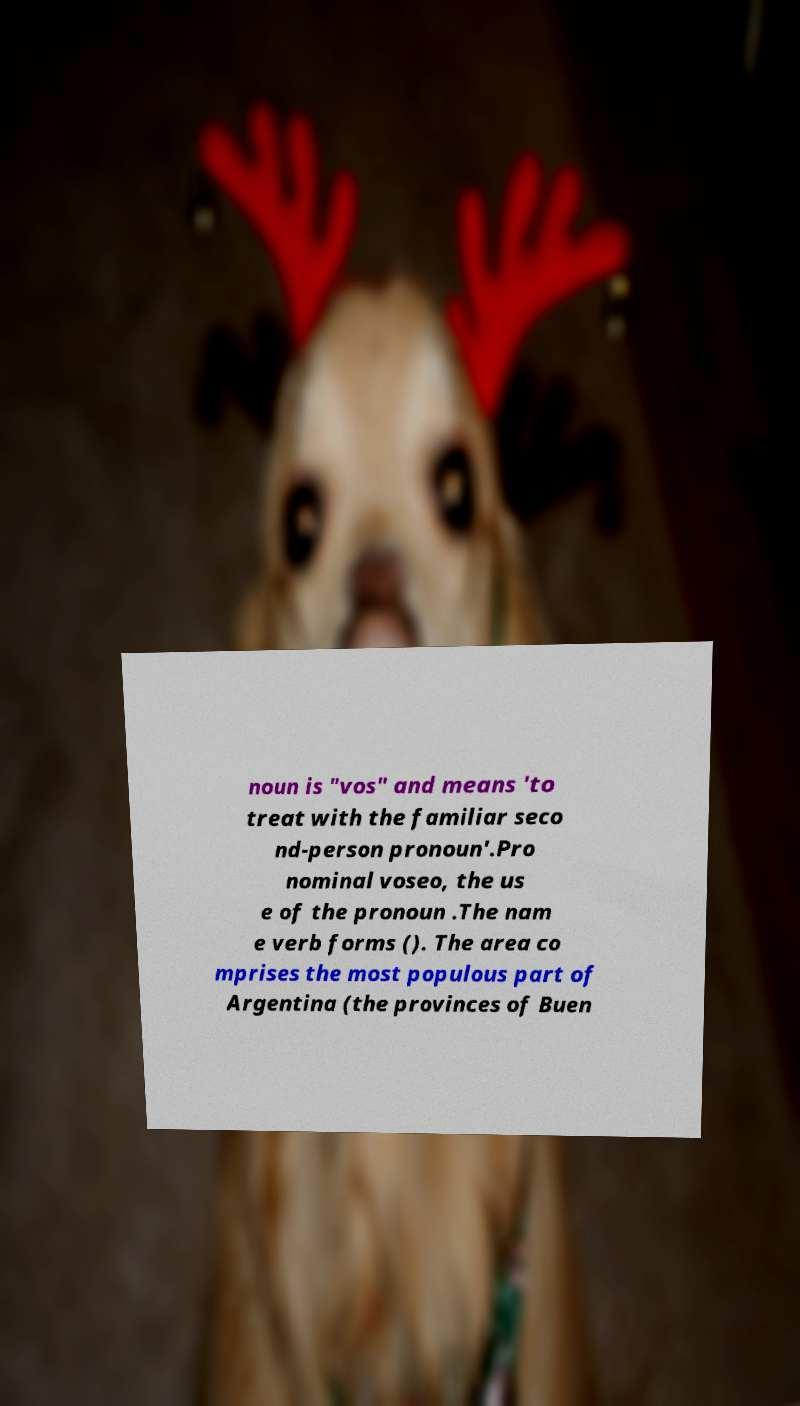Please identify and transcribe the text found in this image. noun is "vos" and means 'to treat with the familiar seco nd-person pronoun'.Pro nominal voseo, the us e of the pronoun .The nam e verb forms (). The area co mprises the most populous part of Argentina (the provinces of Buen 